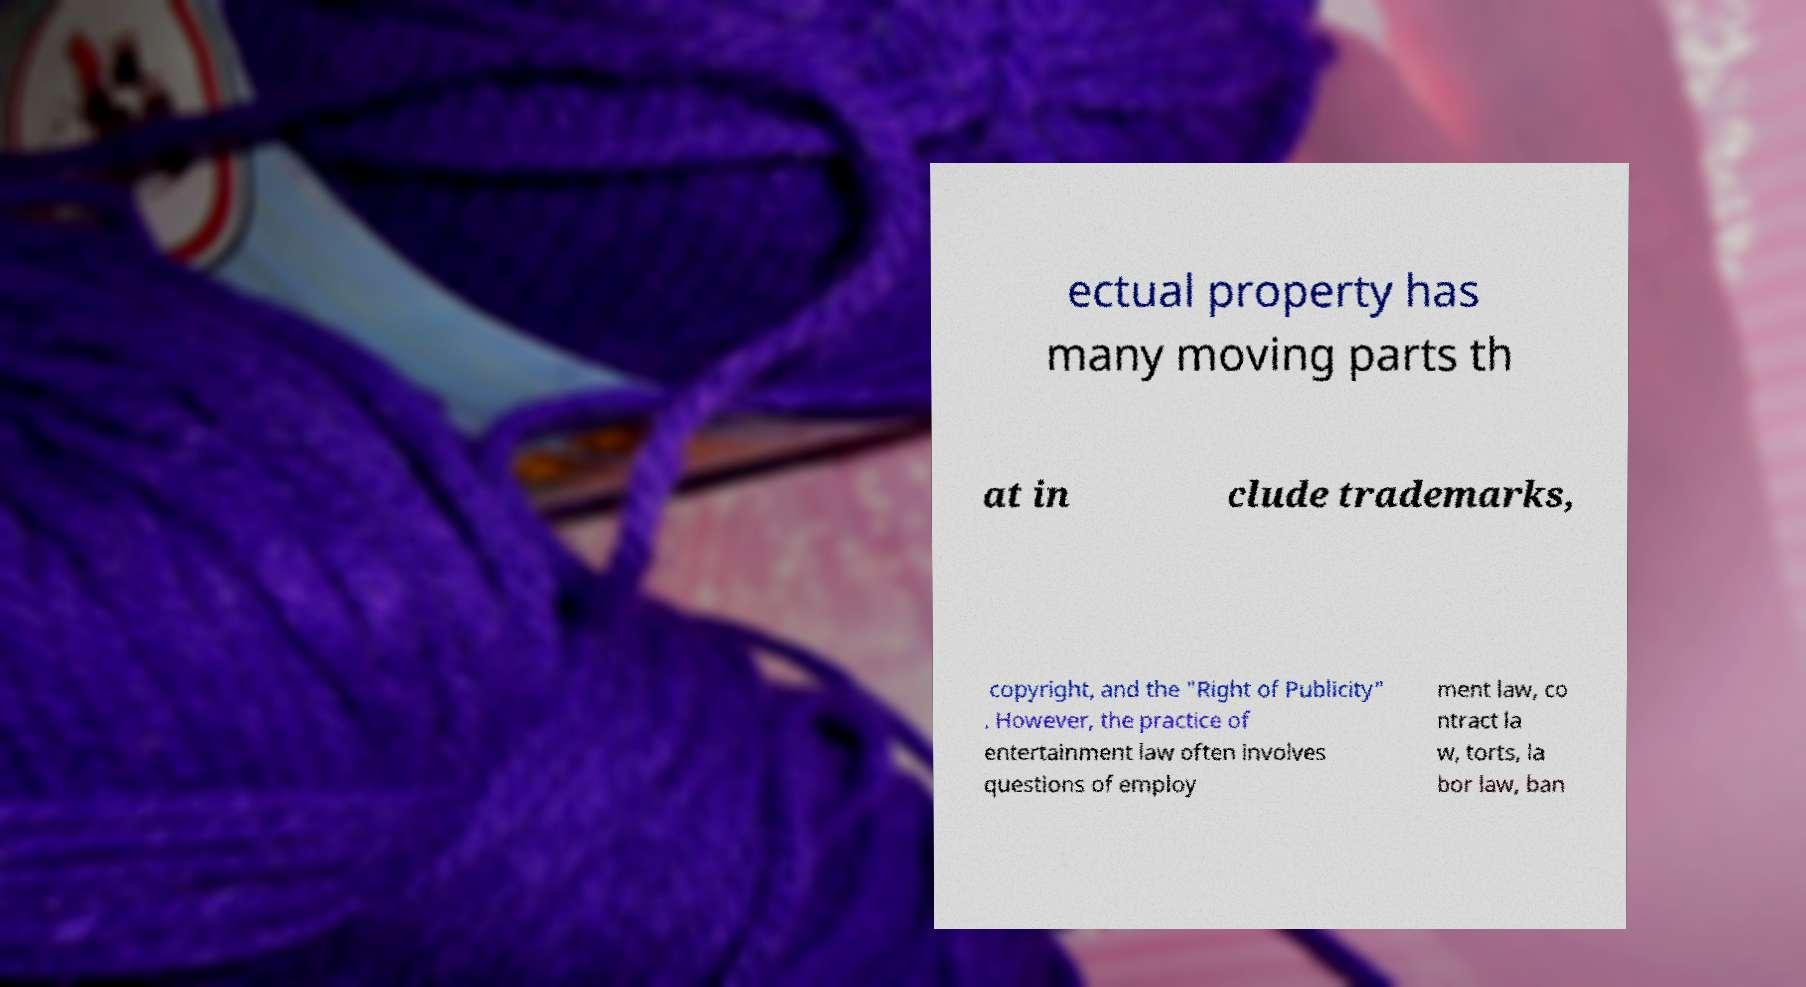There's text embedded in this image that I need extracted. Can you transcribe it verbatim? ectual property has many moving parts th at in clude trademarks, copyright, and the "Right of Publicity" . However, the practice of entertainment law often involves questions of employ ment law, co ntract la w, torts, la bor law, ban 